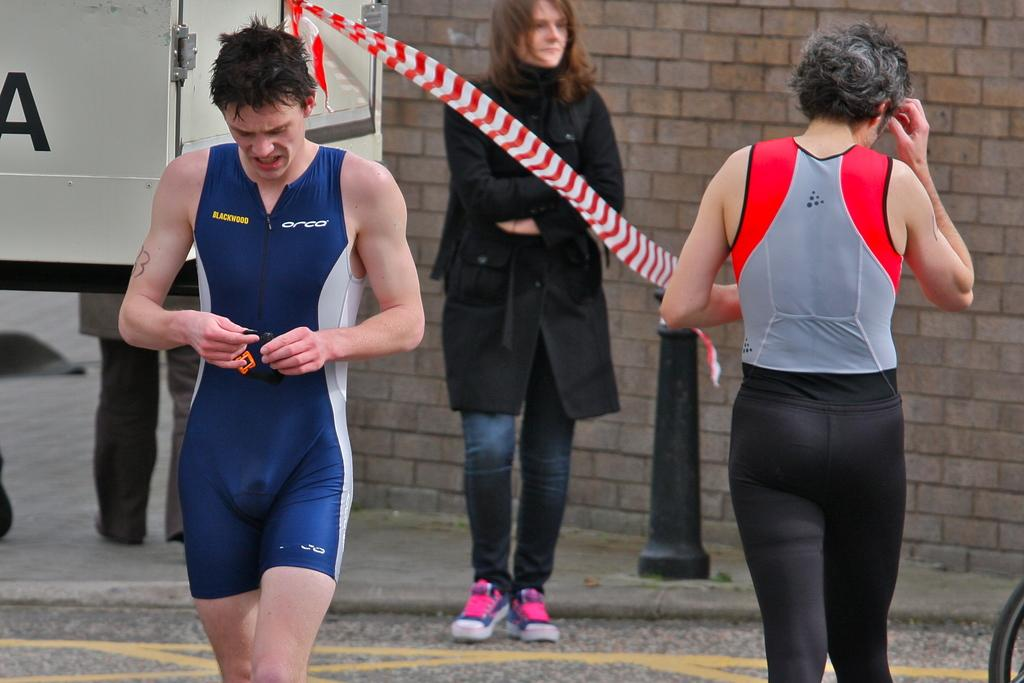<image>
Give a short and clear explanation of the subsequent image. Athlete in a blue uniform with blackwood on the right side in yellow. 